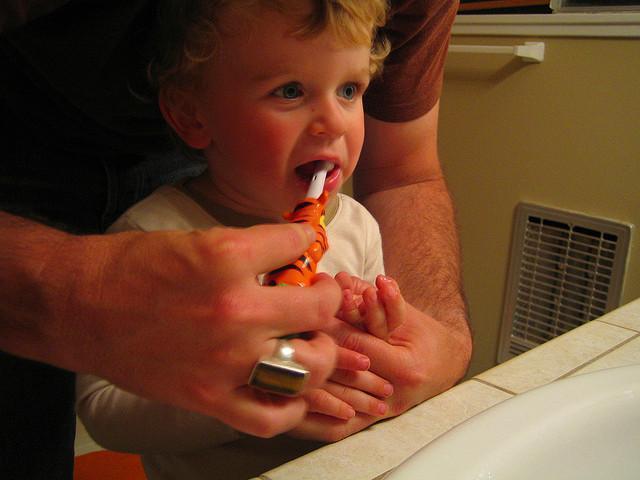What type of animal is the cartoon figure portrayed here based?
Select the correct answer and articulate reasoning with the following format: 'Answer: answer
Rationale: rationale.'
Options: Tiger, pigeon, dog, owl. Answer: tiger.
Rationale: The animal looks like a tiger. 